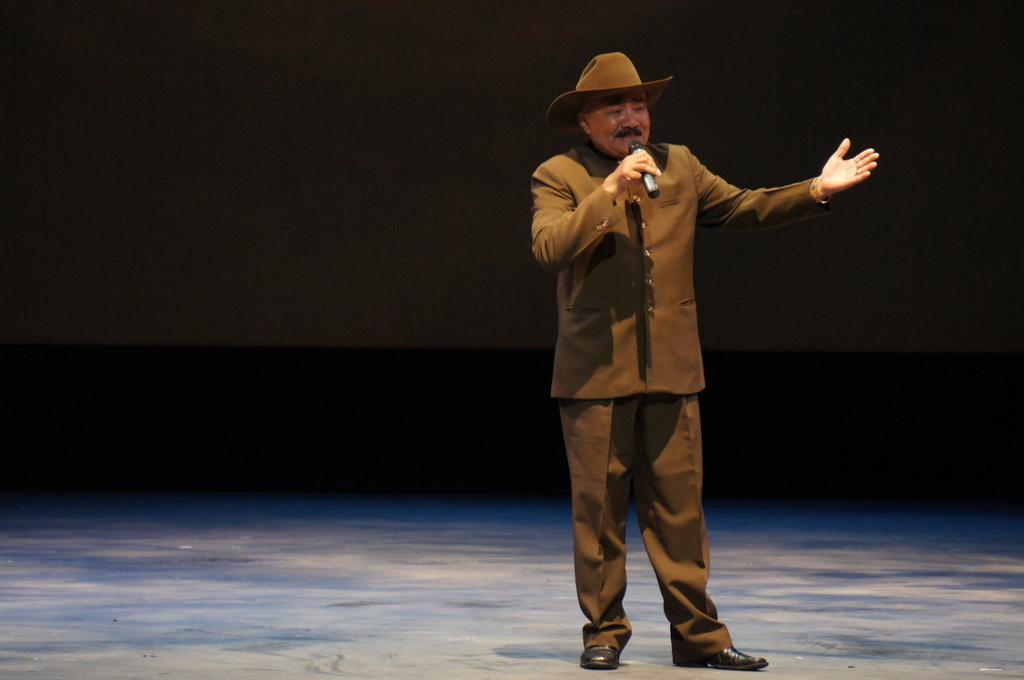Can you describe this image briefly? In this image I can see a person standing and wearing brown color dress and the person is holding a microphone, and I can see dark background. 